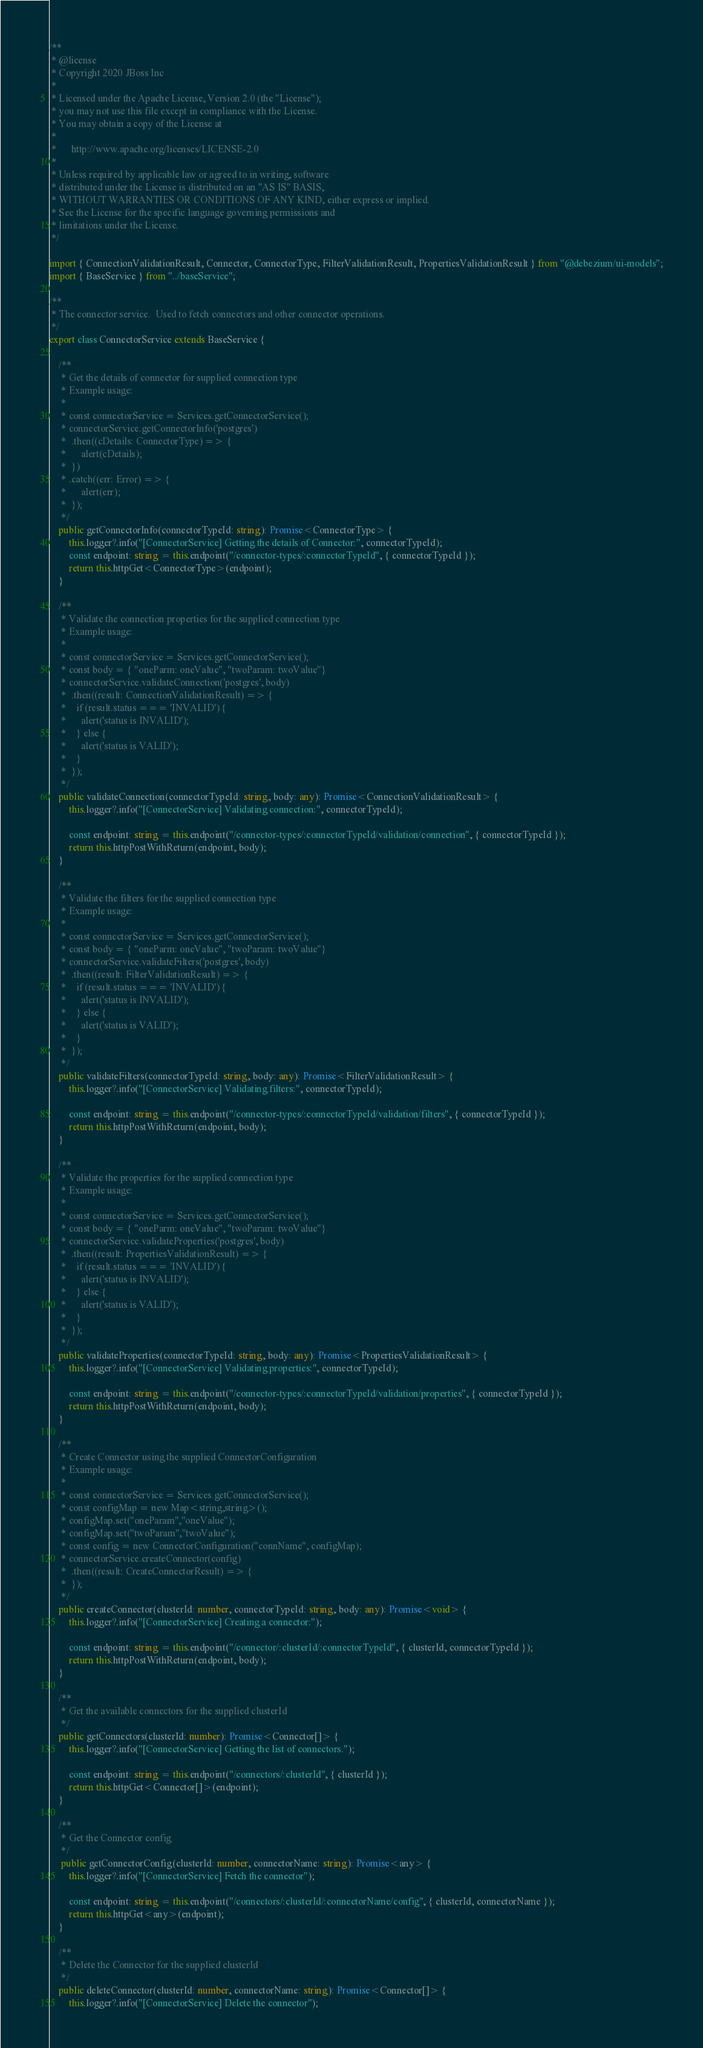<code> <loc_0><loc_0><loc_500><loc_500><_TypeScript_>/**
 * @license
 * Copyright 2020 JBoss Inc
 *
 * Licensed under the Apache License, Version 2.0 (the "License");
 * you may not use this file except in compliance with the License.
 * You may obtain a copy of the License at
 *
 *      http://www.apache.org/licenses/LICENSE-2.0
 *
 * Unless required by applicable law or agreed to in writing, software
 * distributed under the License is distributed on an "AS IS" BASIS,
 * WITHOUT WARRANTIES OR CONDITIONS OF ANY KIND, either express or implied.
 * See the License for the specific language governing permissions and
 * limitations under the License.
 */

import { ConnectionValidationResult, Connector, ConnectorType, FilterValidationResult, PropertiesValidationResult } from "@debezium/ui-models";
import { BaseService } from "../baseService";

/**
 * The connector service.  Used to fetch connectors and other connector operations.
 */
export class ConnectorService extends BaseService {

    /**
     * Get the details of connector for supplied connection type
     * Example usage:
     * 
     * const connectorService = Services.getConnectorService();
     * connectorService.getConnectorInfo('postgres')
     *  .then((cDetails: ConnectorType) => {
     *      alert(cDetails);
     *  })
     * .catch((err: Error) => {
     *      alert(err);
     *  });
     */
    public getConnectorInfo(connectorTypeId: string): Promise<ConnectorType> {
        this.logger?.info("[ConnectorService] Getting the details of Connector:", connectorTypeId);
        const endpoint: string = this.endpoint("/connector-types/:connectorTypeId", { connectorTypeId });
        return this.httpGet<ConnectorType>(endpoint);
    }

    /**
     * Validate the connection properties for the supplied connection type
     * Example usage:
     * 
     * const connectorService = Services.getConnectorService();
     * const body = { "oneParm: oneValue", "twoParam: twoValue"}
     * connectorService.validateConnection('postgres', body)
     *  .then((result: ConnectionValidationResult) => {
     *    if (result.status === 'INVALID') {
     *      alert('status is INVALID');
     *    } else {
     *      alert('status is VALID');
     *    }
     *  });
     */
    public validateConnection(connectorTypeId: string, body: any): Promise<ConnectionValidationResult> {
        this.logger?.info("[ConnectorService] Validating connection:", connectorTypeId);

        const endpoint: string = this.endpoint("/connector-types/:connectorTypeId/validation/connection", { connectorTypeId });
        return this.httpPostWithReturn(endpoint, body);
    }

    /**
     * Validate the filters for the supplied connection type
     * Example usage:
     * 
     * const connectorService = Services.getConnectorService();
     * const body = { "oneParm: oneValue", "twoParam: twoValue"}
     * connectorService.validateFilters('postgres', body)
     *  .then((result: FilterValidationResult) => {
     *    if (result.status === 'INVALID') {
     *      alert('status is INVALID');
     *    } else {
     *      alert('status is VALID');
     *    }
     *  });
     */
    public validateFilters(connectorTypeId: string, body: any): Promise<FilterValidationResult> {
        this.logger?.info("[ConnectorService] Validating filters:", connectorTypeId);

        const endpoint: string = this.endpoint("/connector-types/:connectorTypeId/validation/filters", { connectorTypeId });
        return this.httpPostWithReturn(endpoint, body);
    }

    /**
     * Validate the properties for the supplied connection type
     * Example usage:
     * 
     * const connectorService = Services.getConnectorService();
     * const body = { "oneParm: oneValue", "twoParam: twoValue"}
     * connectorService.validateProperties('postgres', body)
     *  .then((result: PropertiesValidationResult) => {
     *    if (result.status === 'INVALID') {
     *      alert('status is INVALID');
     *    } else {
     *      alert('status is VALID');
     *    }
     *  });
     */
    public validateProperties(connectorTypeId: string, body: any): Promise<PropertiesValidationResult> {
        this.logger?.info("[ConnectorService] Validating properties:", connectorTypeId);

        const endpoint: string = this.endpoint("/connector-types/:connectorTypeId/validation/properties", { connectorTypeId });
        return this.httpPostWithReturn(endpoint, body);
    }

    /**
     * Create Connector using the supplied ConnectorConfiguration
     * Example usage:
     * 
     * const connectorService = Services.getConnectorService();
     * const configMap = new Map<string,string>();
     * configMap.set("oneParam","oneValue");
     * configMap.set("twoParam","twoValue");
     * const config = new ConnectorConfiguration("connName", configMap);
     * connectorService.createConnector(config)
     *  .then((result: CreateConnectorResult) => {
     *  });
     */
    public createConnector(clusterId: number, connectorTypeId: string, body: any): Promise<void> {
        this.logger?.info("[ConnectorService] Creating a connector:");

        const endpoint: string = this.endpoint("/connector/:clusterId/:connectorTypeId", { clusterId, connectorTypeId });
        return this.httpPostWithReturn(endpoint, body);
    }

    /**
     * Get the available connectors for the supplied clusterId
     */
    public getConnectors(clusterId: number): Promise<Connector[]> {
        this.logger?.info("[ConnectorService] Getting the list of connectors.");

        const endpoint: string = this.endpoint("/connectors/:clusterId", { clusterId });
        return this.httpGet<Connector[]>(endpoint);
    }

    /**
     * Get the Connector config
     */
     public getConnectorConfig(clusterId: number, connectorName: string): Promise<any> {
        this.logger?.info("[ConnectorService] Fetch the connector");

        const endpoint: string = this.endpoint("/connectors/:clusterId/:connectorName/config", { clusterId, connectorName });
        return this.httpGet<any>(endpoint);
    }

    /**
     * Delete the Connector for the supplied clusterId
     */
    public deleteConnector(clusterId: number, connectorName: string): Promise<Connector[]> {
        this.logger?.info("[ConnectorService] Delete the connector");
</code> 